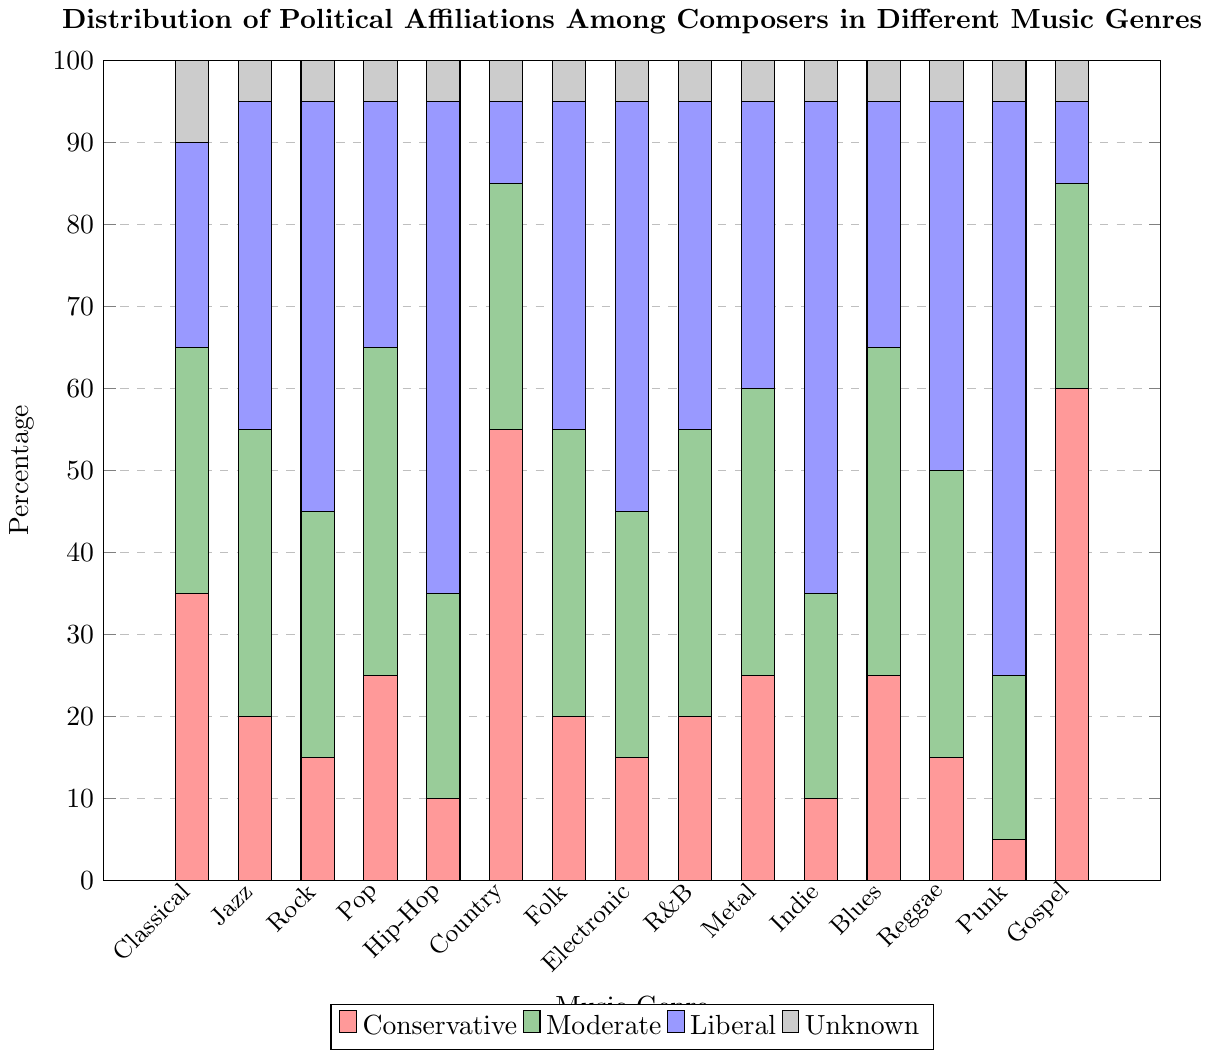What music genre has the highest percentage of conservative composers? The bar representing Gospel music has the tallest section colored in red, indicating the highest percentage of conservative composers.
Answer: Gospel Which music genre has the lowest percentage of unknown political affiliations? All genres have the smallest section of the bar in gray, which is consistently the same height across all genres, indicating that the percentage is equal for all.
Answer: All genres In which music genre is the percentage of liberal composers more than double the percentage of conservative composers? For Punk, the height of the blue section representing liberal composers is 70, while the red section representing conservative composers is 5. 70 is more than double of 5.
Answer: Punk Which genre has the most evenly distributed political affiliations among conservative, moderate, and liberal categories? The Metal genre has bars of comparable height for red (conservative), green (moderate), and blue (liberal), all around 25-35%.
Answer: Metal For which genre is the percentage of moderate composers exactly equal to the sum of conservative and unknown composers? For Blues, the green section (moderate) is 40%, and the sum of the red section (conservative) 25% and gray section (unknown) 5% is also 30%. Therefore, it is incorrect. It might be Rab 35%.
Answer: Rab What's the difference between the highest and lowest percentage of liberal composers across all genres? The highest percentage of liberal composers is 70% for Punk, and the lowest is 10% for Country and Gospel. The difference is 70 - 10.
Answer: 60% Which genre has the highest combined percentage of conservative and moderate composers? For Gospel, the red section (conservative) is 60 and the green (moderate) is 25, making a total of 85. This is the highest combined percentage.
Answer: Gospel In which genre is the percentage of moderate composers greater than the sum of liberal and conservative composers? All possible genres should be checked, but from the data, none of the genres have green section (moderate) greater than the sum of the red and blue section (conservative and liberal).
Answer: None Which two genres have the exact same percentage of liberal composers but different percentages of moderate composers? Jazz and R&B both have 40% (blue section) liberal composers, but for moderate composers (green section), Jazz has 35% and R&B has 35%.
Answer: Jazz and R&B 